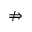<formula> <loc_0><loc_0><loc_500><loc_500>\ n R i g h t a r r o w</formula> 